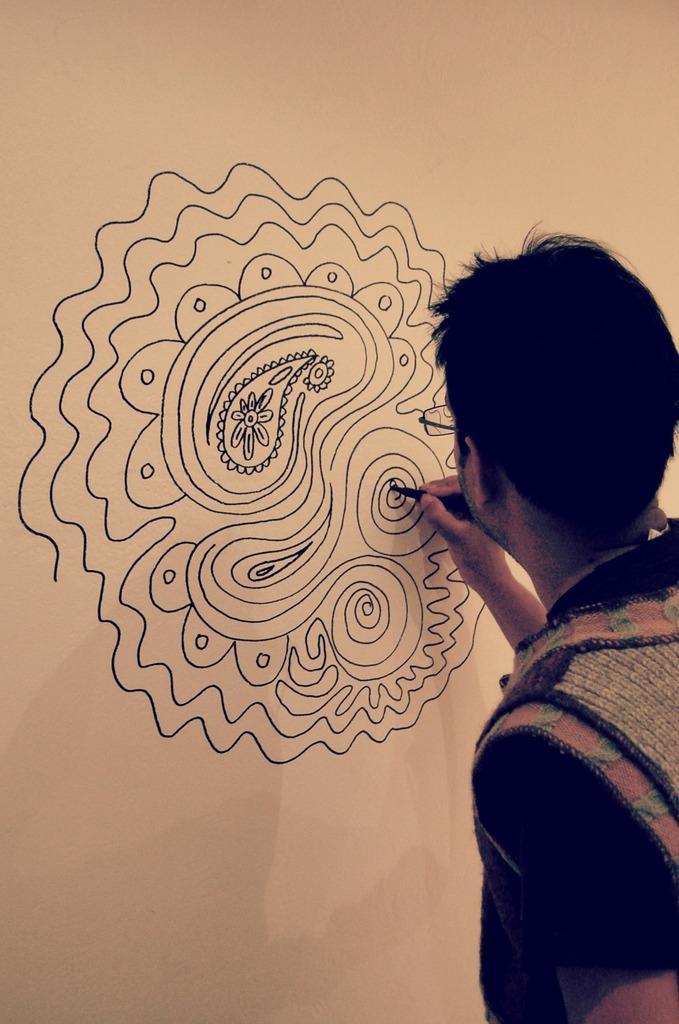How would you summarize this image in a sentence or two? In this image I can see a person drawing on a wall. He is wearing spectacles. 